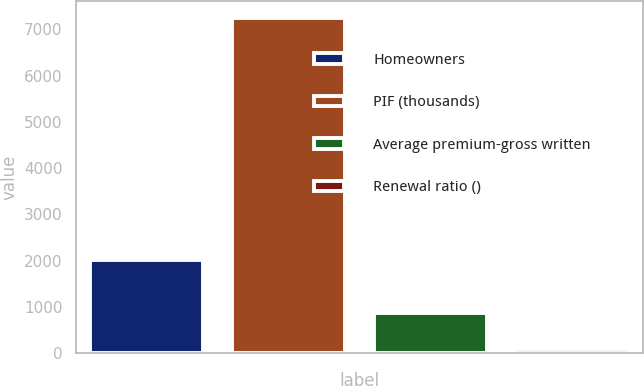Convert chart. <chart><loc_0><loc_0><loc_500><loc_500><bar_chart><fcel>Homeowners<fcel>PIF (thousands)<fcel>Average premium-gross written<fcel>Renewal ratio ()<nl><fcel>2008<fcel>7255<fcel>861<fcel>87<nl></chart> 